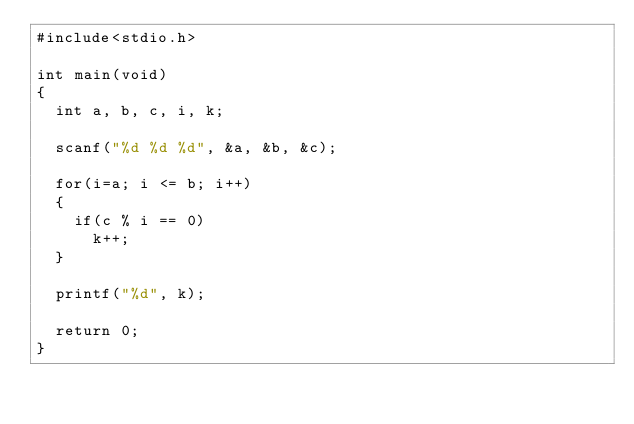<code> <loc_0><loc_0><loc_500><loc_500><_C_>#include<stdio.h>

int main(void)
{
  int a, b, c, i, k;

  scanf("%d %d %d", &a, &b, &c);

  for(i=a; i <= b; i++)
  {
    if(c % i == 0)
      k++;
  }
  
  printf("%d", k);

  return 0;
}

</code> 